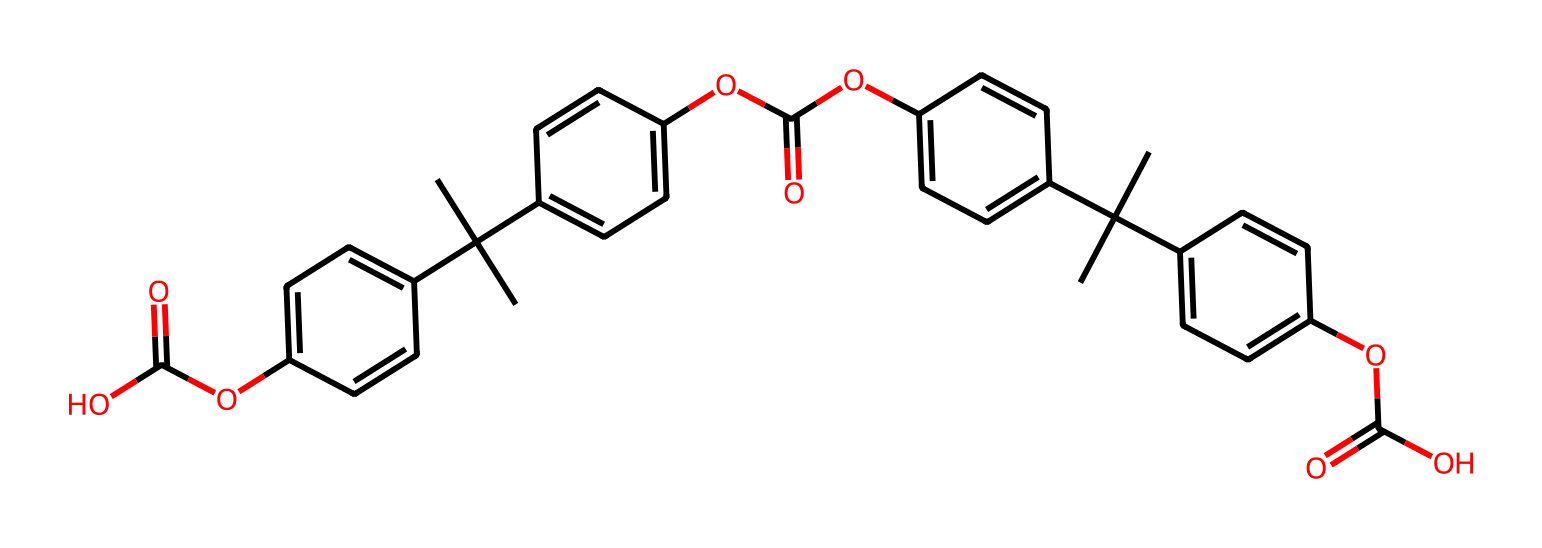What is the total number of carbon atoms in this chemical? By examining the SMILES representation, we can count the occurrences of 'C' which represents carbon atoms. There are 21 carbon atoms in the structure.
Answer: 21 How many ester functional groups are present in this chemical? The SMILES notation contains "OC(=O)", which corresponds to an ester functionality. Counting these groups in the chemical structure indicates that there are three ester groups.
Answer: 3 Which functional group is present that indicates the compound can potentially act as an antioxidant? The presence of multiple hydroxyl groups (-OH) suggests that this compound could act as an antioxidant due to their ability to donate electrons and neutralize free radicals.
Answer: hydroxyl Does this chemical contain a benzene ring? The presence of 'c' in the SMILES indicates that there are aromatic (benzene) rings in the structure. Scanning the structure shows there are four aromatic rings.
Answer: four What type of compound is characterized by the presence of carbon and oxygen in an ester arrangement? The presence of carbonyl (C=O) and the ether group (C-O) indicates that it is an ester, which is a type of organic compound formed from the reaction between an alcohol and an acid.
Answer: ester 